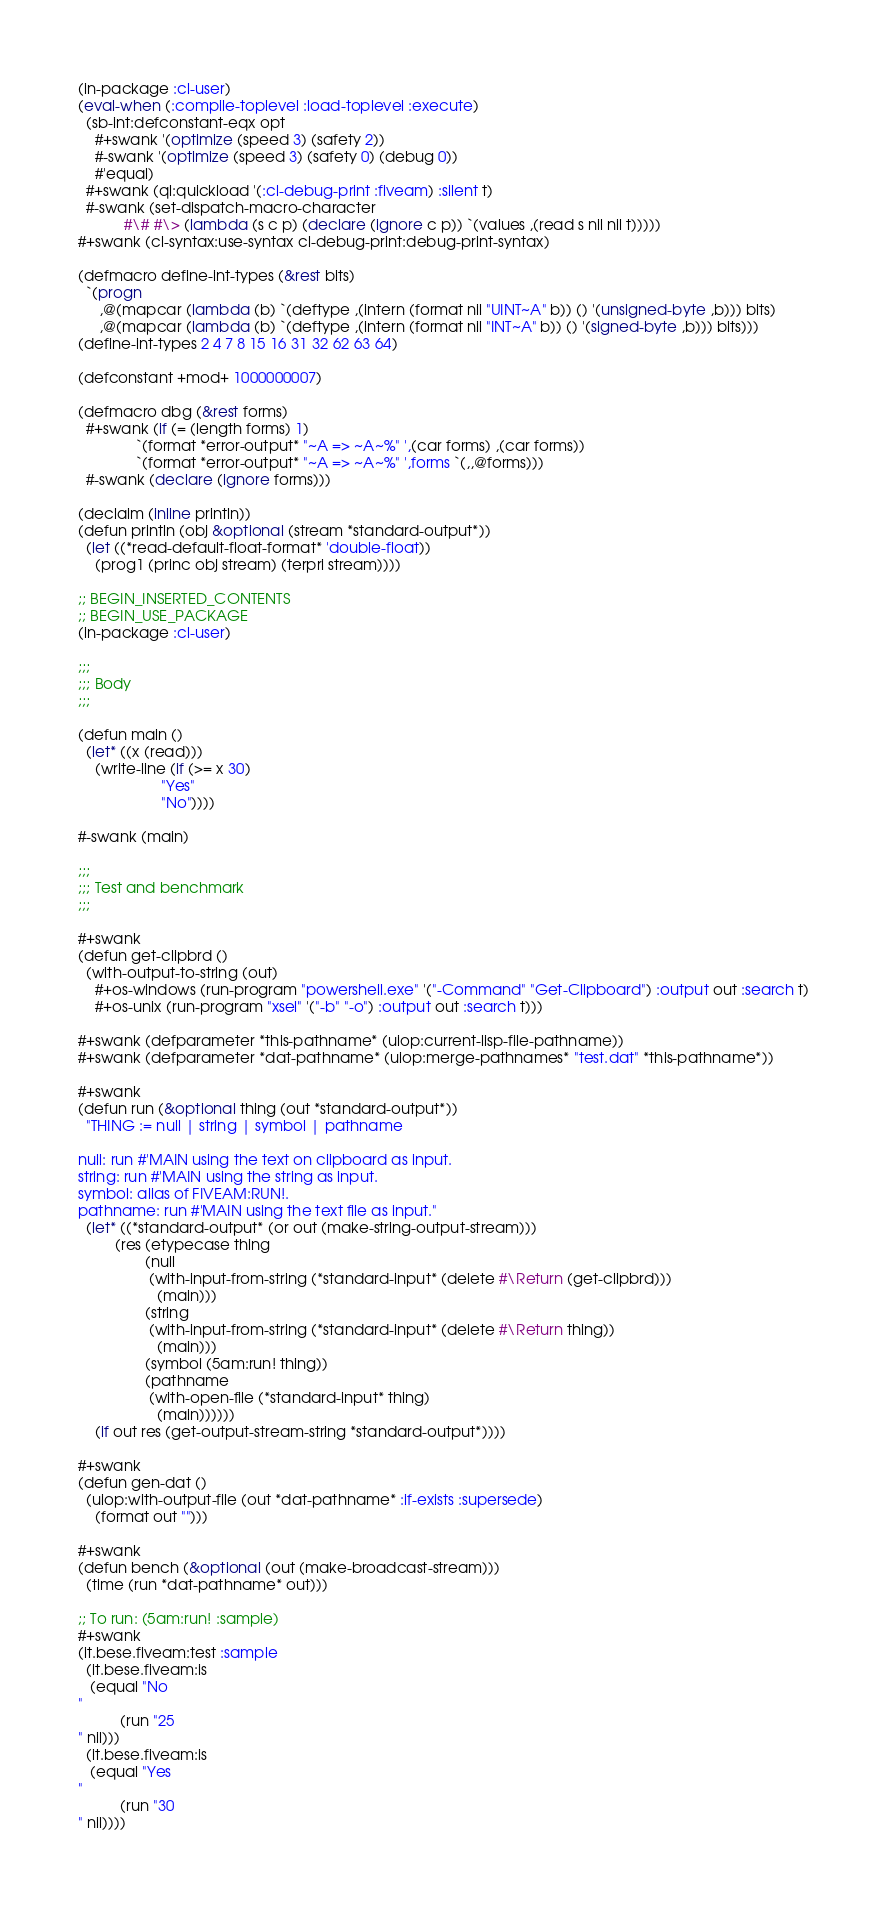<code> <loc_0><loc_0><loc_500><loc_500><_Lisp_>(in-package :cl-user)
(eval-when (:compile-toplevel :load-toplevel :execute)
  (sb-int:defconstant-eqx opt
    #+swank '(optimize (speed 3) (safety 2))
    #-swank '(optimize (speed 3) (safety 0) (debug 0))
    #'equal)
  #+swank (ql:quickload '(:cl-debug-print :fiveam) :silent t)
  #-swank (set-dispatch-macro-character
           #\# #\> (lambda (s c p) (declare (ignore c p)) `(values ,(read s nil nil t)))))
#+swank (cl-syntax:use-syntax cl-debug-print:debug-print-syntax)

(defmacro define-int-types (&rest bits)
  `(progn
     ,@(mapcar (lambda (b) `(deftype ,(intern (format nil "UINT~A" b)) () '(unsigned-byte ,b))) bits)
     ,@(mapcar (lambda (b) `(deftype ,(intern (format nil "INT~A" b)) () '(signed-byte ,b))) bits)))
(define-int-types 2 4 7 8 15 16 31 32 62 63 64)

(defconstant +mod+ 1000000007)

(defmacro dbg (&rest forms)
  #+swank (if (= (length forms) 1)
              `(format *error-output* "~A => ~A~%" ',(car forms) ,(car forms))
              `(format *error-output* "~A => ~A~%" ',forms `(,,@forms)))
  #-swank (declare (ignore forms)))

(declaim (inline println))
(defun println (obj &optional (stream *standard-output*))
  (let ((*read-default-float-format* 'double-float))
    (prog1 (princ obj stream) (terpri stream))))

;; BEGIN_INSERTED_CONTENTS
;; BEGIN_USE_PACKAGE
(in-package :cl-user)

;;;
;;; Body
;;;

(defun main ()
  (let* ((x (read)))
    (write-line (if (>= x 30)
                    "Yes"
                    "No"))))

#-swank (main)

;;;
;;; Test and benchmark
;;;

#+swank
(defun get-clipbrd ()
  (with-output-to-string (out)
    #+os-windows (run-program "powershell.exe" '("-Command" "Get-Clipboard") :output out :search t)
    #+os-unix (run-program "xsel" '("-b" "-o") :output out :search t)))

#+swank (defparameter *this-pathname* (uiop:current-lisp-file-pathname))
#+swank (defparameter *dat-pathname* (uiop:merge-pathnames* "test.dat" *this-pathname*))

#+swank
(defun run (&optional thing (out *standard-output*))
  "THING := null | string | symbol | pathname

null: run #'MAIN using the text on clipboard as input.
string: run #'MAIN using the string as input.
symbol: alias of FIVEAM:RUN!.
pathname: run #'MAIN using the text file as input."
  (let* ((*standard-output* (or out (make-string-output-stream)))
         (res (etypecase thing
                (null
                 (with-input-from-string (*standard-input* (delete #\Return (get-clipbrd)))
                   (main)))
                (string
                 (with-input-from-string (*standard-input* (delete #\Return thing))
                   (main)))
                (symbol (5am:run! thing))
                (pathname
                 (with-open-file (*standard-input* thing)
                   (main))))))
    (if out res (get-output-stream-string *standard-output*))))

#+swank
(defun gen-dat ()
  (uiop:with-output-file (out *dat-pathname* :if-exists :supersede)
    (format out "")))

#+swank
(defun bench (&optional (out (make-broadcast-stream)))
  (time (run *dat-pathname* out)))

;; To run: (5am:run! :sample)
#+swank
(it.bese.fiveam:test :sample
  (it.bese.fiveam:is
   (equal "No
"
          (run "25
" nil)))
  (it.bese.fiveam:is
   (equal "Yes
"
          (run "30
" nil))))
</code> 